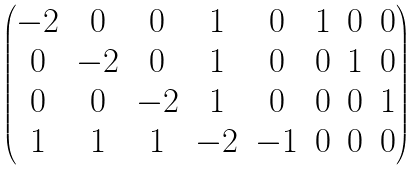<formula> <loc_0><loc_0><loc_500><loc_500>\begin{pmatrix} - 2 & 0 & 0 & 1 & 0 & 1 & 0 & 0 \\ 0 & - 2 & 0 & 1 & 0 & 0 & 1 & 0 \\ 0 & 0 & - 2 & 1 & 0 & 0 & 0 & 1 \\ 1 & 1 & 1 & - 2 & - 1 & 0 & 0 & 0 \end{pmatrix}</formula> 